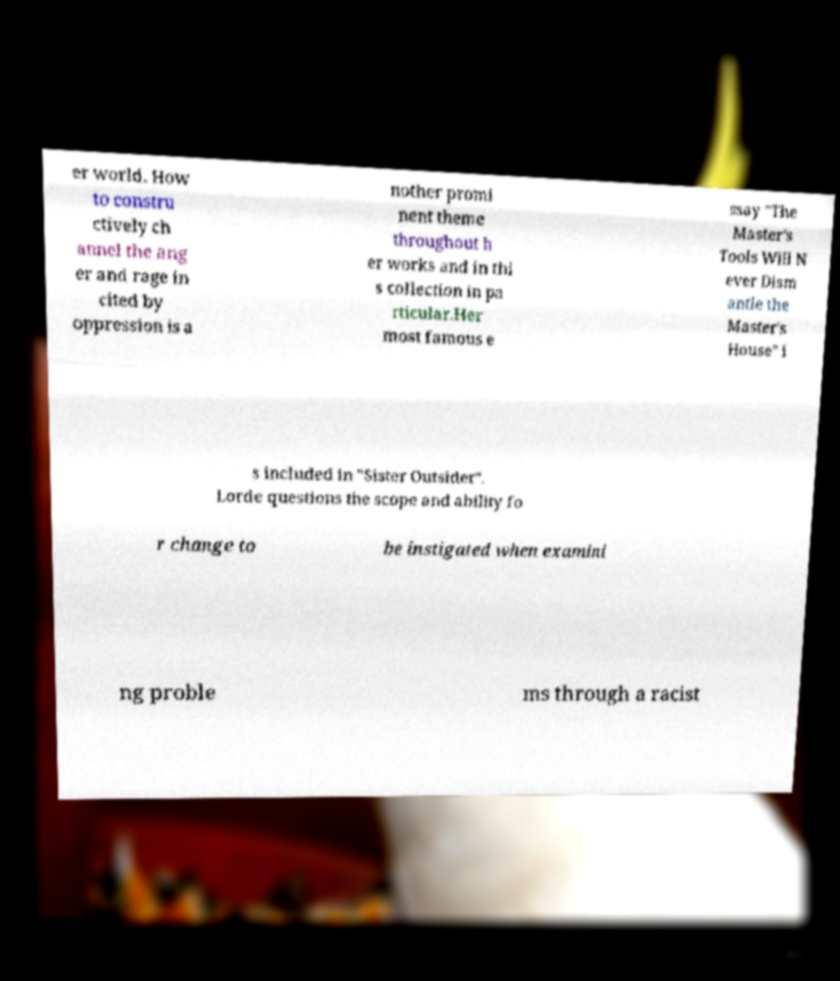Please identify and transcribe the text found in this image. er world. How to constru ctively ch annel the ang er and rage in cited by oppression is a nother promi nent theme throughout h er works and in thi s collection in pa rticular.Her most famous e ssay "The Master's Tools Will N ever Dism antle the Master's House" i s included in "Sister Outsider". Lorde questions the scope and ability fo r change to be instigated when examini ng proble ms through a racist 